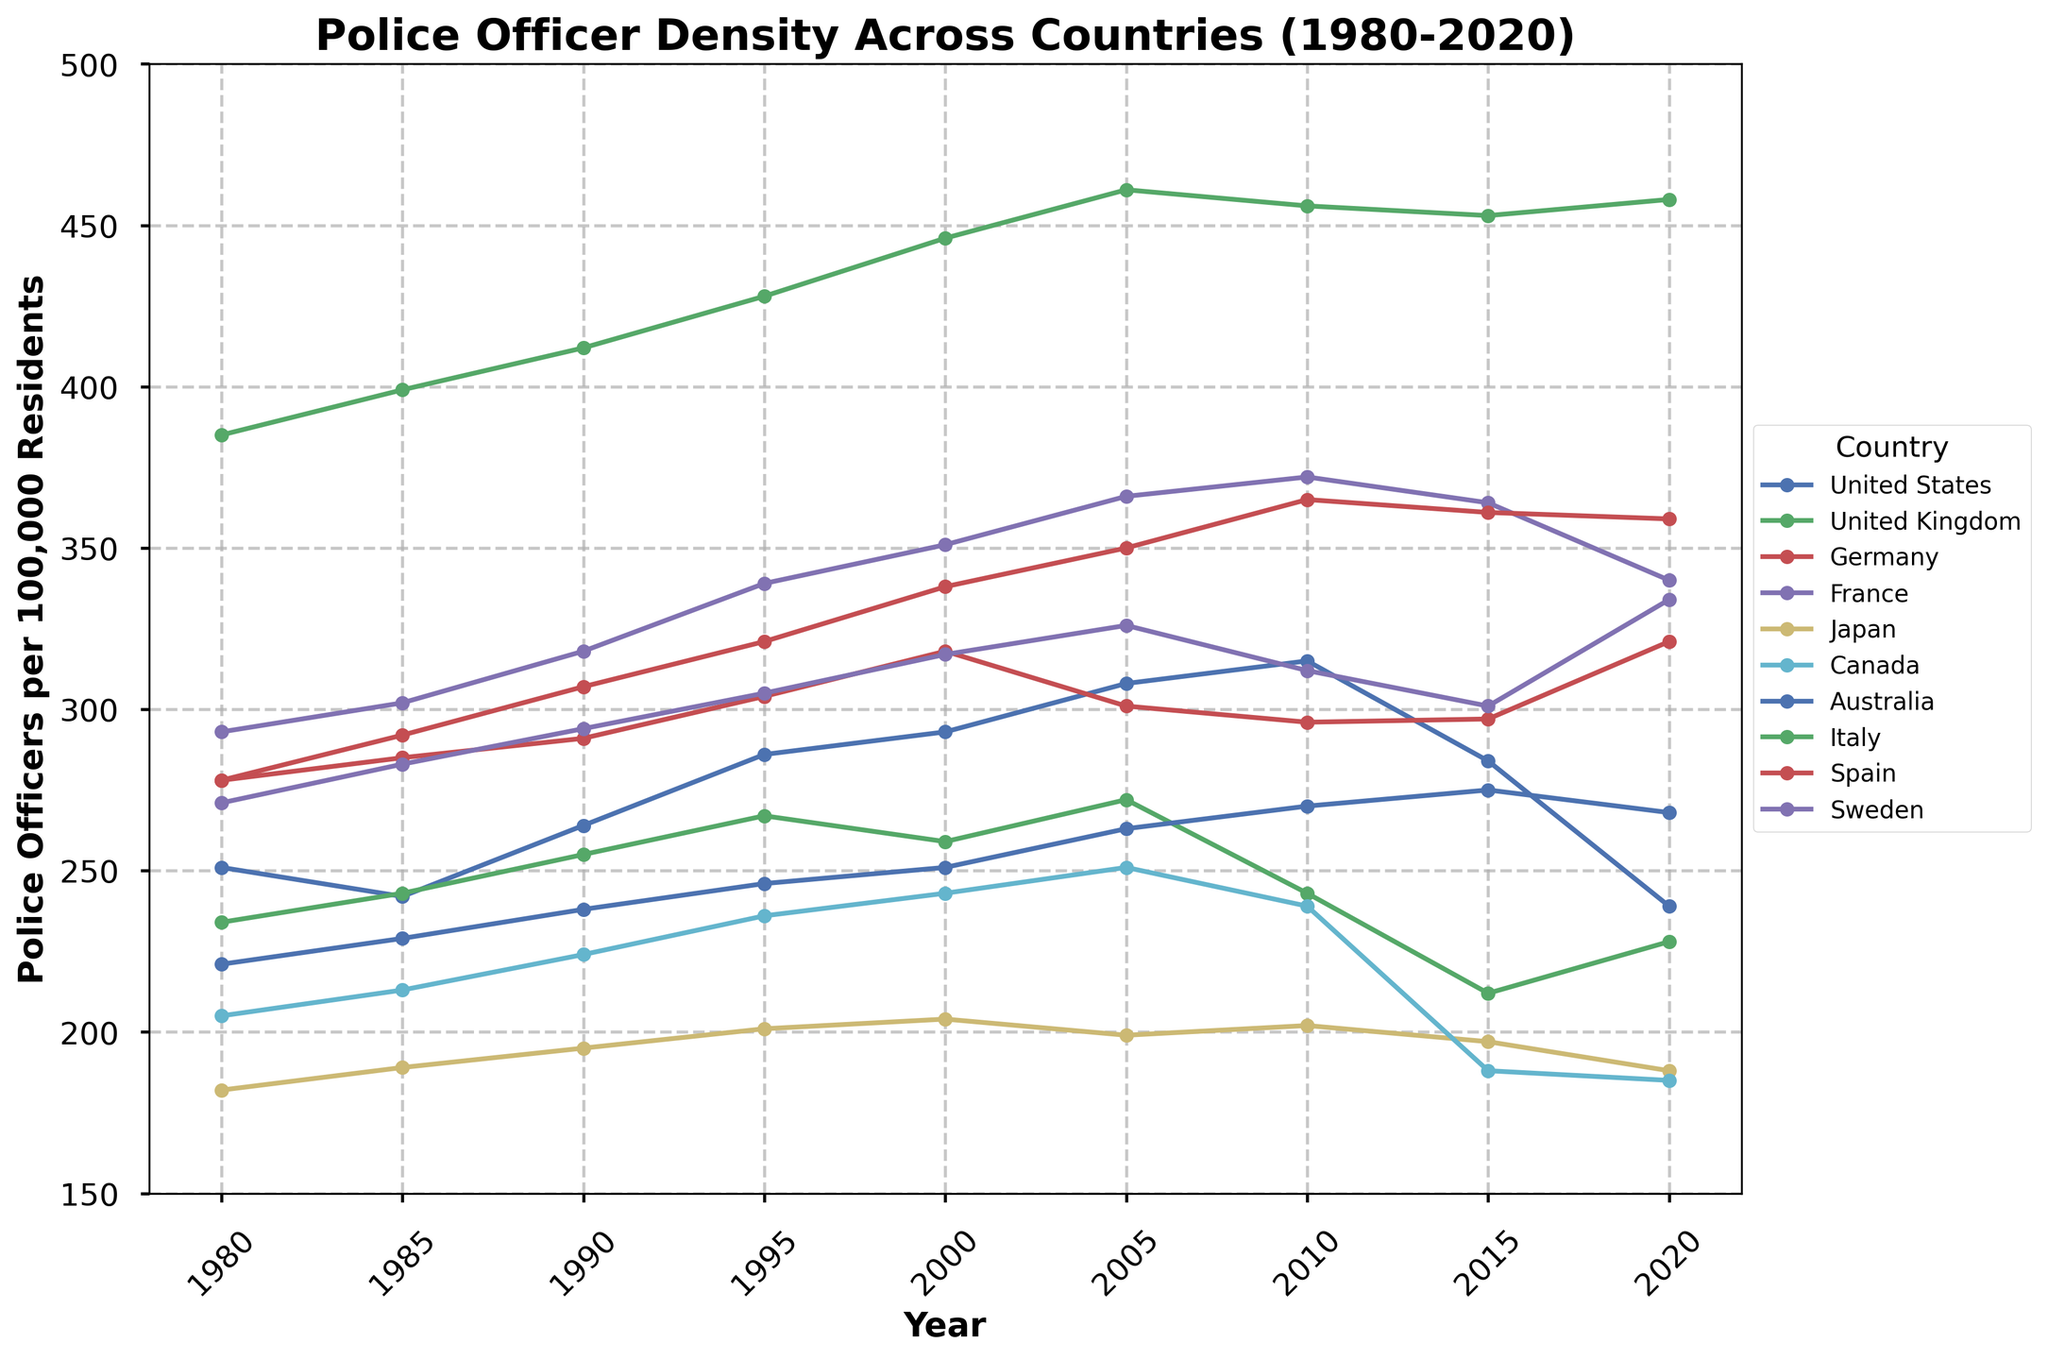What is the general trend of police officers per 100,000 residents in the Japan from 1980 to 2020? By looking at the line representing Japan from 1980 to 2020, the number of police officers per 100,000 residents starts at 182 in 1980, gradually increases to a peak of around 204 in 2000, and then reduces back to 188 in 2020, indicating an increasing then decreasing trend over the 40 years.
Answer: Increasing then decreasing trend Which country had the highest police officer density in 2020? The line for Italy is at the topmost position among all countries in 2020, indicating it has the highest police officer density at around 458 per 100,000 residents.
Answer: Italy By how much has the police officer density changed for the United States from 1980 to 2020? In 1980, the number of police officers per 100,000 residents in the United States is 251, and in 2020, it is 239. The change is calculated as 251 - 239 = 12.
Answer: 12 Which countries had a peak in police officer density between 2010 and 2015? From the lines, the United States, France, and Canada show a noticeable peak within the period 2010 to 2015 where their police officer densities are the highest compared to other times.
Answer: United States, France, and Canada What is the difference in police officer density between France and Germany in the year 2000? From the graph, the police officer density in France in 2000 is around 351, and in Germany, it is about 318. Subtracting these values gives 351 - 318 = 33.
Answer: 33 Which country had the most stable police officer density over the 40-year period? By observing all the lines, the lines representing Japan and Canada remain relatively stable without sharp increases or decreases, indicating their densities are most stable over the period. Among these, Japan shows slightly less fluctuation.
Answer: Japan In which year did Sweden surpass Germany in police officer density? By comparing the lines, Sweden's police officer density surpasses Germany’s in 2020 when Sweden reaches approximately 334 and Germany reaches around 321.
Answer: 2020 